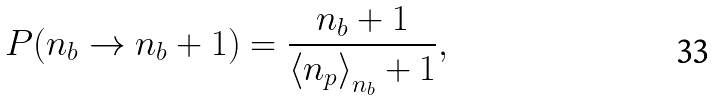<formula> <loc_0><loc_0><loc_500><loc_500>P ( n _ { b } \to n _ { b } + 1 ) = \frac { n _ { b } + 1 } { \left < n _ { p } \right > _ { n _ { b } } + 1 } ,</formula> 